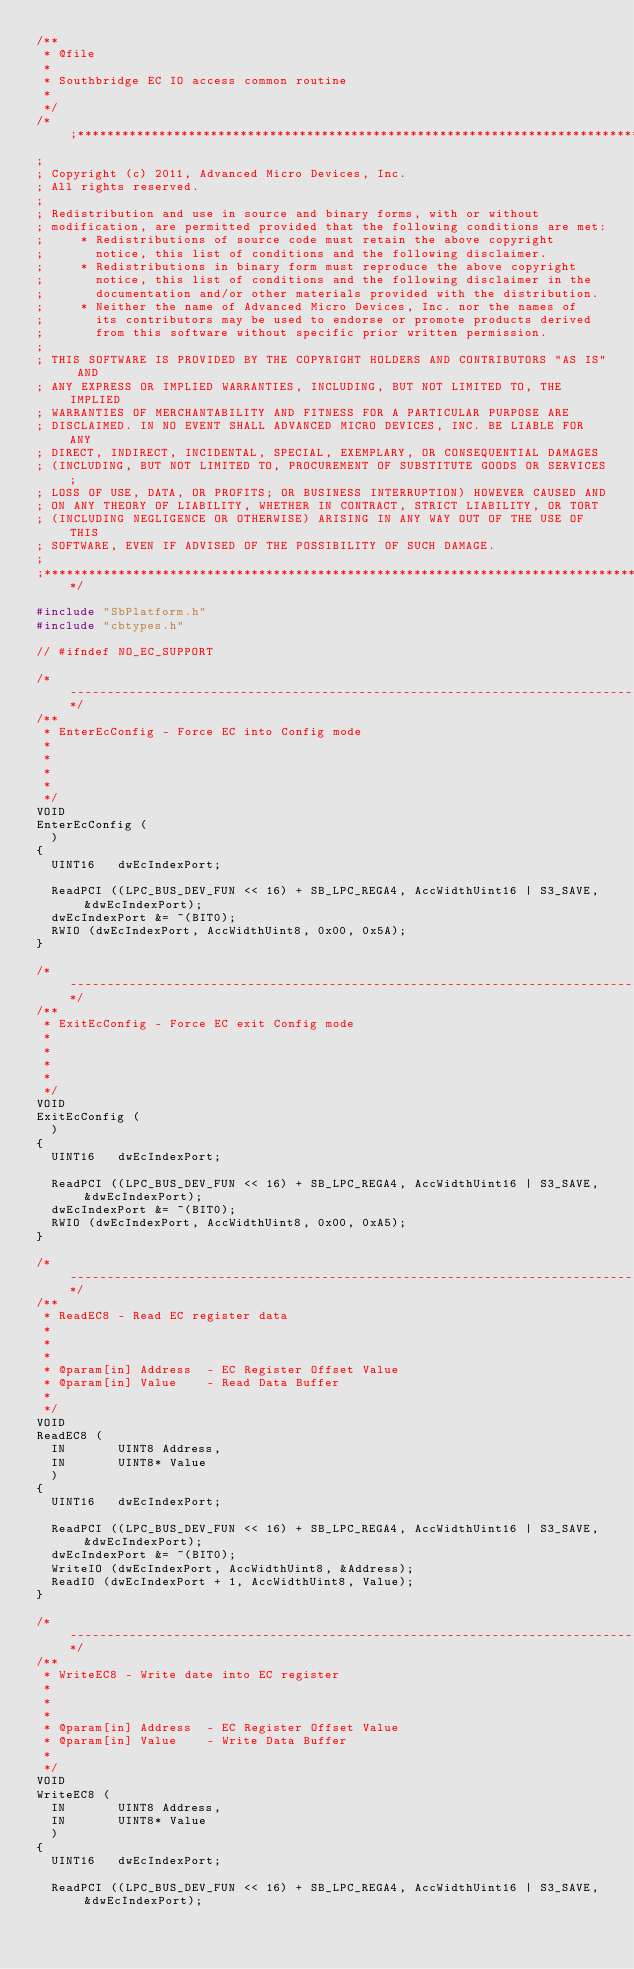Convert code to text. <code><loc_0><loc_0><loc_500><loc_500><_C_>/**
 * @file
 *
 * Southbridge EC IO access common routine
 *
 */
/*;********************************************************************************
;
; Copyright (c) 2011, Advanced Micro Devices, Inc.
; All rights reserved.
; 
; Redistribution and use in source and binary forms, with or without
; modification, are permitted provided that the following conditions are met:
;     * Redistributions of source code must retain the above copyright
;       notice, this list of conditions and the following disclaimer.
;     * Redistributions in binary form must reproduce the above copyright
;       notice, this list of conditions and the following disclaimer in the
;       documentation and/or other materials provided with the distribution.
;     * Neither the name of Advanced Micro Devices, Inc. nor the names of 
;       its contributors may be used to endorse or promote products derived 
;       from this software without specific prior written permission.
; 
; THIS SOFTWARE IS PROVIDED BY THE COPYRIGHT HOLDERS AND CONTRIBUTORS "AS IS" AND
; ANY EXPRESS OR IMPLIED WARRANTIES, INCLUDING, BUT NOT LIMITED TO, THE IMPLIED
; WARRANTIES OF MERCHANTABILITY AND FITNESS FOR A PARTICULAR PURPOSE ARE
; DISCLAIMED. IN NO EVENT SHALL ADVANCED MICRO DEVICES, INC. BE LIABLE FOR ANY
; DIRECT, INDIRECT, INCIDENTAL, SPECIAL, EXEMPLARY, OR CONSEQUENTIAL DAMAGES
; (INCLUDING, BUT NOT LIMITED TO, PROCUREMENT OF SUBSTITUTE GOODS OR SERVICES;
; LOSS OF USE, DATA, OR PROFITS; OR BUSINESS INTERRUPTION) HOWEVER CAUSED AND
; ON ANY THEORY OF LIABILITY, WHETHER IN CONTRACT, STRICT LIABILITY, OR TORT
; (INCLUDING NEGLIGENCE OR OTHERWISE) ARISING IN ANY WAY OUT OF THE USE OF THIS
; SOFTWARE, EVEN IF ADVISED OF THE POSSIBILITY OF SUCH DAMAGE.
; 
;*********************************************************************************/

#include "SbPlatform.h"
#include "cbtypes.h"

// #ifndef NO_EC_SUPPORT

/*----------------------------------------------------------------------------------------*/
/**
 * EnterEcConfig - Force EC into Config mode
 *
 *
 *
 *
 */
VOID
EnterEcConfig (
  )
{
  UINT16   dwEcIndexPort;

  ReadPCI ((LPC_BUS_DEV_FUN << 16) + SB_LPC_REGA4, AccWidthUint16 | S3_SAVE, &dwEcIndexPort);
  dwEcIndexPort &= ~(BIT0);
  RWIO (dwEcIndexPort, AccWidthUint8, 0x00, 0x5A);
}

/*----------------------------------------------------------------------------------------*/
/**
 * ExitEcConfig - Force EC exit Config mode
 *
 *
 *
 *
 */
VOID
ExitEcConfig (
  )
{
  UINT16   dwEcIndexPort;

  ReadPCI ((LPC_BUS_DEV_FUN << 16) + SB_LPC_REGA4, AccWidthUint16 | S3_SAVE, &dwEcIndexPort);
  dwEcIndexPort &= ~(BIT0);
  RWIO (dwEcIndexPort, AccWidthUint8, 0x00, 0xA5);
}

/*----------------------------------------------------------------------------------------*/
/**
 * ReadEC8 - Read EC register data
 *
 *
 *
 * @param[in] Address  - EC Register Offset Value
 * @param[in] Value    - Read Data Buffer
 *
 */
VOID
ReadEC8 (
  IN       UINT8 Address,
  IN       UINT8* Value
  )
{
  UINT16   dwEcIndexPort;

  ReadPCI ((LPC_BUS_DEV_FUN << 16) + SB_LPC_REGA4, AccWidthUint16 | S3_SAVE, &dwEcIndexPort);
  dwEcIndexPort &= ~(BIT0);
  WriteIO (dwEcIndexPort, AccWidthUint8, &Address);
  ReadIO (dwEcIndexPort + 1, AccWidthUint8, Value);
}

/*----------------------------------------------------------------------------------------*/
/**
 * WriteEC8 - Write date into EC register
 *
 *
 *
 * @param[in] Address  - EC Register Offset Value
 * @param[in] Value    - Write Data Buffer
 *
 */
VOID
WriteEC8 (
  IN       UINT8 Address,
  IN       UINT8* Value
  )
{
  UINT16   dwEcIndexPort;

  ReadPCI ((LPC_BUS_DEV_FUN << 16) + SB_LPC_REGA4, AccWidthUint16 | S3_SAVE, &dwEcIndexPort);</code> 